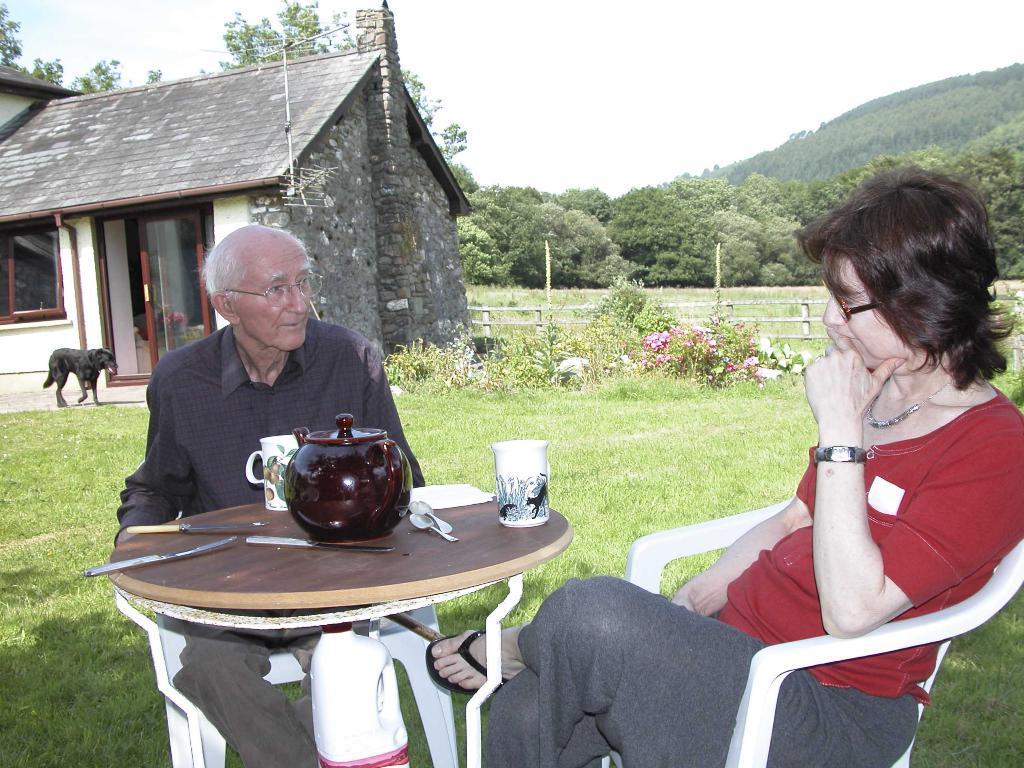Can you describe this image briefly? In the picture there are two people sitting opposite to each other there is a table in between them there is a teapot, few knives and cups on the table behind them there is a house and dog in front of the house , in the background there is a grass, bushes ,trees, a hill and sky. 